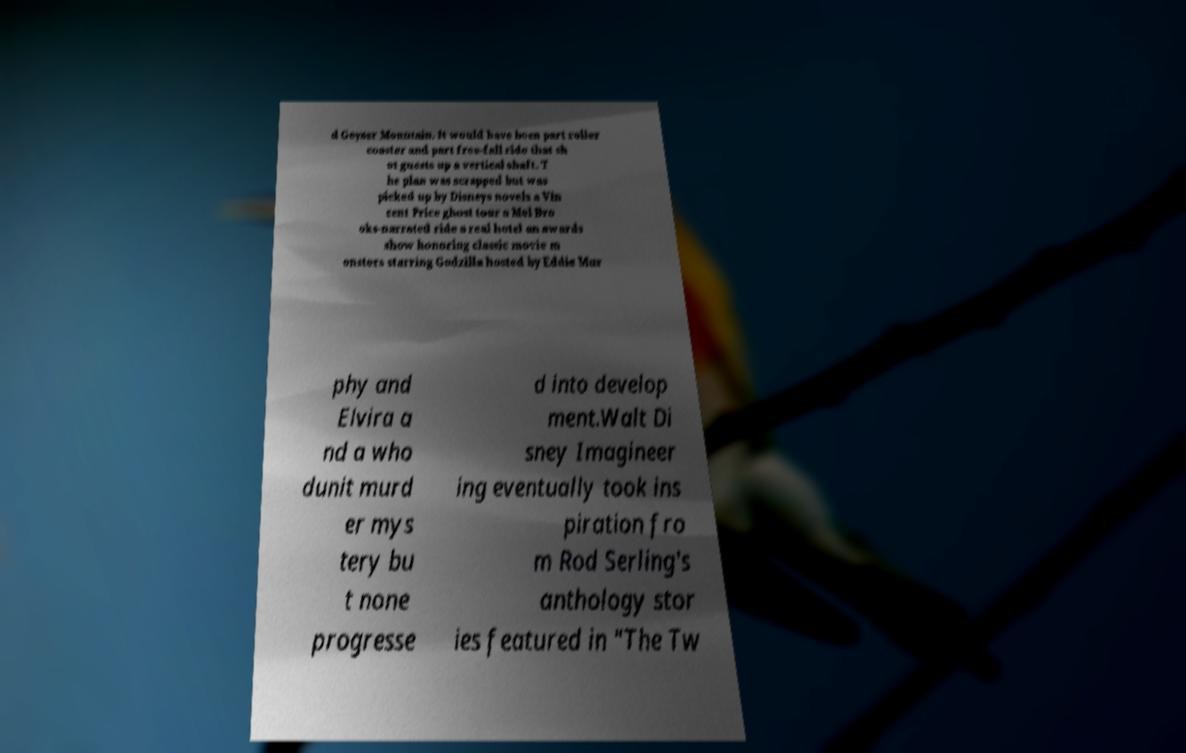What messages or text are displayed in this image? I need them in a readable, typed format. d Geyser Mountain. It would have been part roller coaster and part free-fall ride that sh ot guests up a vertical shaft. T he plan was scrapped but was picked up by Disneys novels a Vin cent Price ghost tour a Mel Bro oks-narrated ride a real hotel an awards show honoring classic movie m onsters starring Godzilla hosted by Eddie Mur phy and Elvira a nd a who dunit murd er mys tery bu t none progresse d into develop ment.Walt Di sney Imagineer ing eventually took ins piration fro m Rod Serling's anthology stor ies featured in "The Tw 